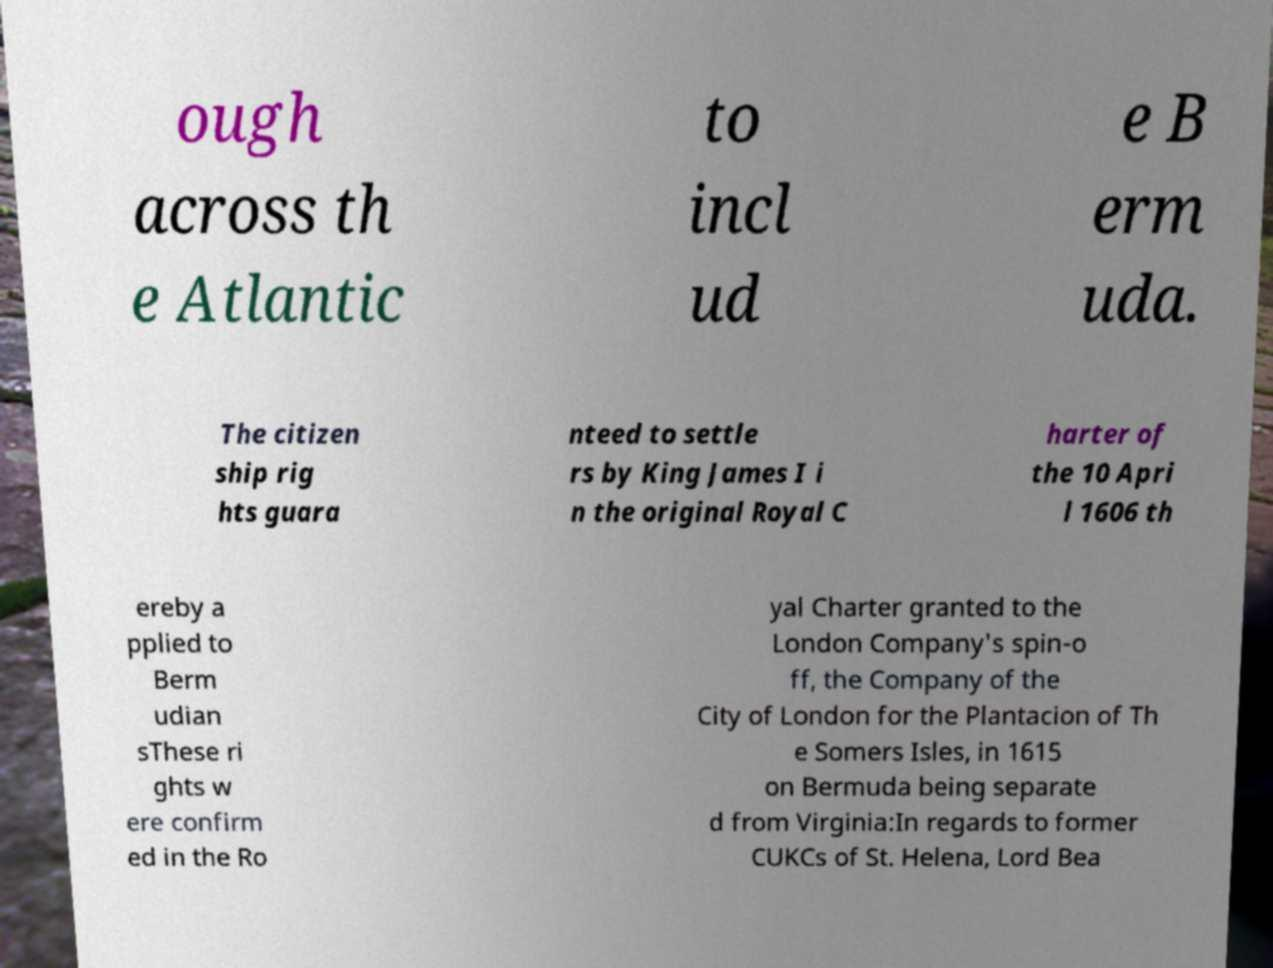There's text embedded in this image that I need extracted. Can you transcribe it verbatim? ough across th e Atlantic to incl ud e B erm uda. The citizen ship rig hts guara nteed to settle rs by King James I i n the original Royal C harter of the 10 Apri l 1606 th ereby a pplied to Berm udian sThese ri ghts w ere confirm ed in the Ro yal Charter granted to the London Company's spin-o ff, the Company of the City of London for the Plantacion of Th e Somers Isles, in 1615 on Bermuda being separate d from Virginia:In regards to former CUKCs of St. Helena, Lord Bea 